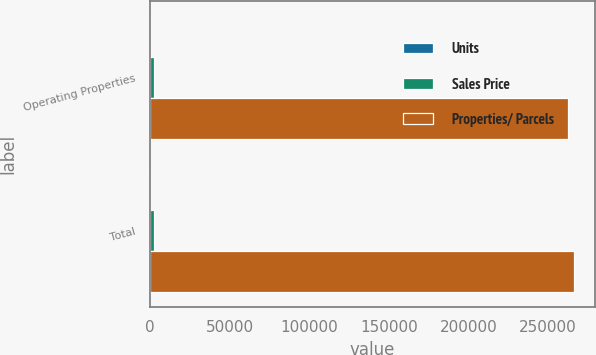Convert chart. <chart><loc_0><loc_0><loc_500><loc_500><stacked_bar_chart><ecel><fcel>Operating Properties<fcel>Total<nl><fcel>Units<fcel>14<fcel>15<nl><fcel>Sales Price<fcel>2712<fcel>2712<nl><fcel>Properties/ Parcels<fcel>262792<fcel>266092<nl></chart> 